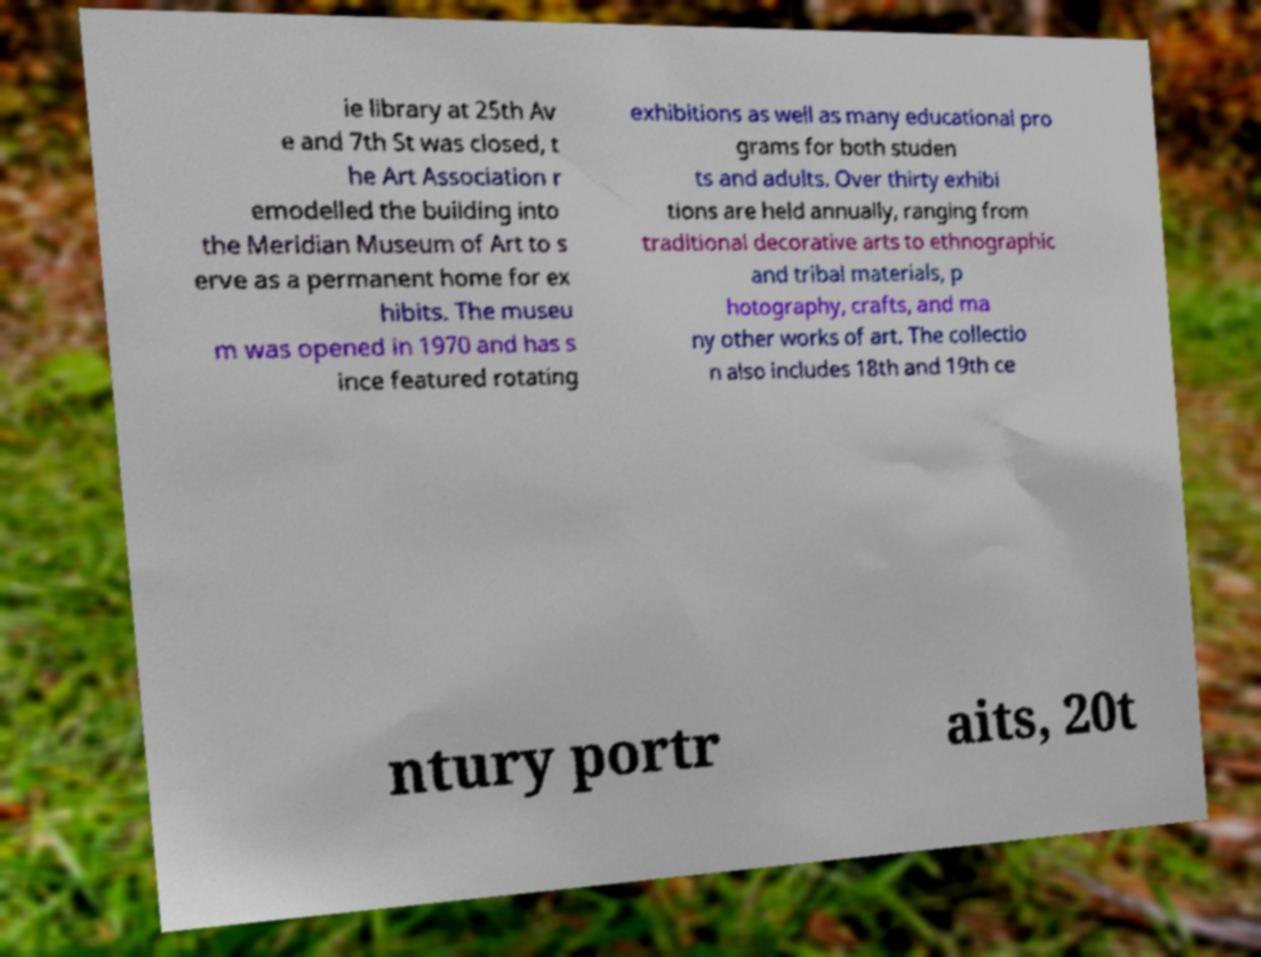Can you accurately transcribe the text from the provided image for me? ie library at 25th Av e and 7th St was closed, t he Art Association r emodelled the building into the Meridian Museum of Art to s erve as a permanent home for ex hibits. The museu m was opened in 1970 and has s ince featured rotating exhibitions as well as many educational pro grams for both studen ts and adults. Over thirty exhibi tions are held annually, ranging from traditional decorative arts to ethnographic and tribal materials, p hotography, crafts, and ma ny other works of art. The collectio n also includes 18th and 19th ce ntury portr aits, 20t 